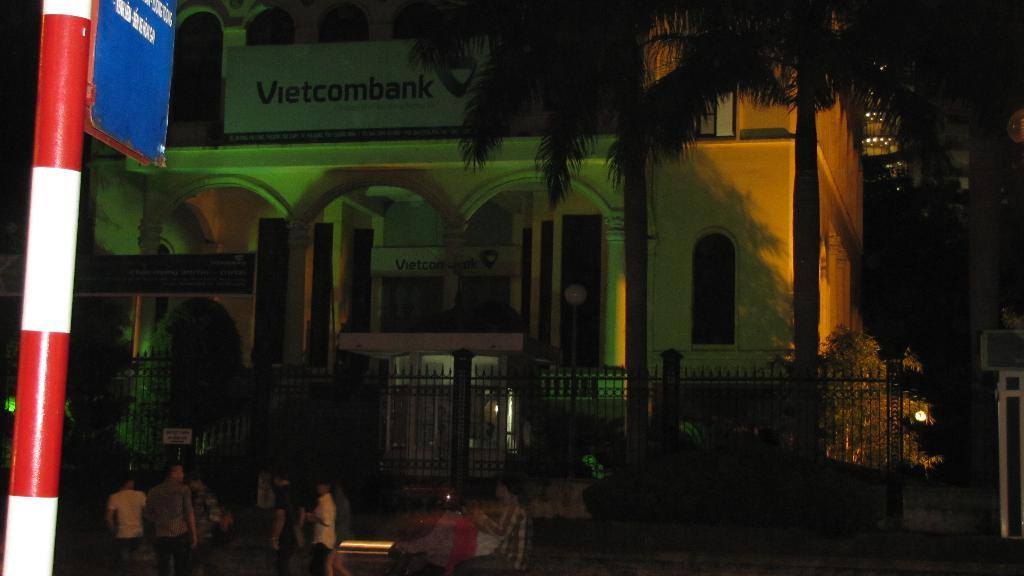What type of vegetation is visible in front of the building? There are trees in front of the building. What kind of barrier can be seen in the image? There is a fencing in the image. Can you describe the people at the bottom of the image? There are persons at the bottom of the image. What is located on the left side of the image? There is a sign board on the left side of the image. What type of horn can be seen on the persons at the bottom of the image? There is no horn present on the persons at the bottom of the image. What color is the nose of the tree in front of the building? Trees do not have noses, so this question cannot be answered. 